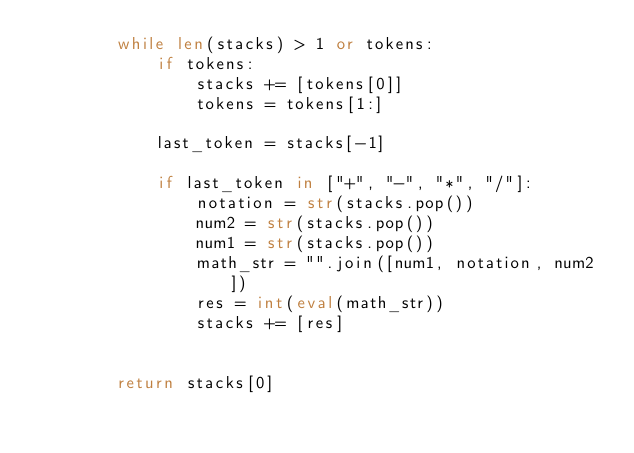Convert code to text. <code><loc_0><loc_0><loc_500><loc_500><_Python_>        while len(stacks) > 1 or tokens:
            if tokens:
                stacks += [tokens[0]]
                tokens = tokens[1:]
            
            last_token = stacks[-1]
            
            if last_token in ["+", "-", "*", "/"]:
                notation = str(stacks.pop())
                num2 = str(stacks.pop())
                num1 = str(stacks.pop())
                math_str = "".join([num1, notation, num2])
                res = int(eval(math_str))
                stacks += [res]

            
        return stacks[0]</code> 